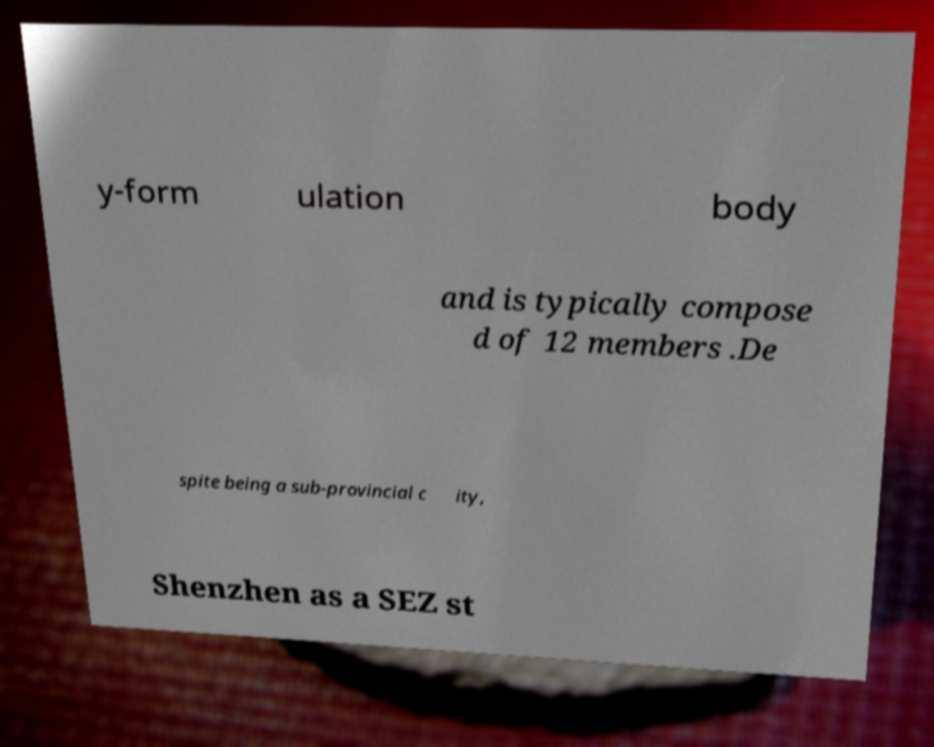I need the written content from this picture converted into text. Can you do that? y-form ulation body and is typically compose d of 12 members .De spite being a sub-provincial c ity, Shenzhen as a SEZ st 